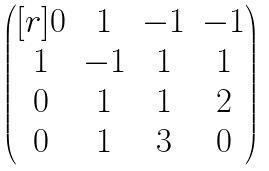<formula> <loc_0><loc_0><loc_500><loc_500>\begin{pmatrix} [ r ] 0 & 1 & - 1 & - 1 \\ 1 & - 1 & 1 & 1 \\ 0 & 1 & 1 & 2 \\ 0 & 1 & 3 & 0 \end{pmatrix}</formula> 